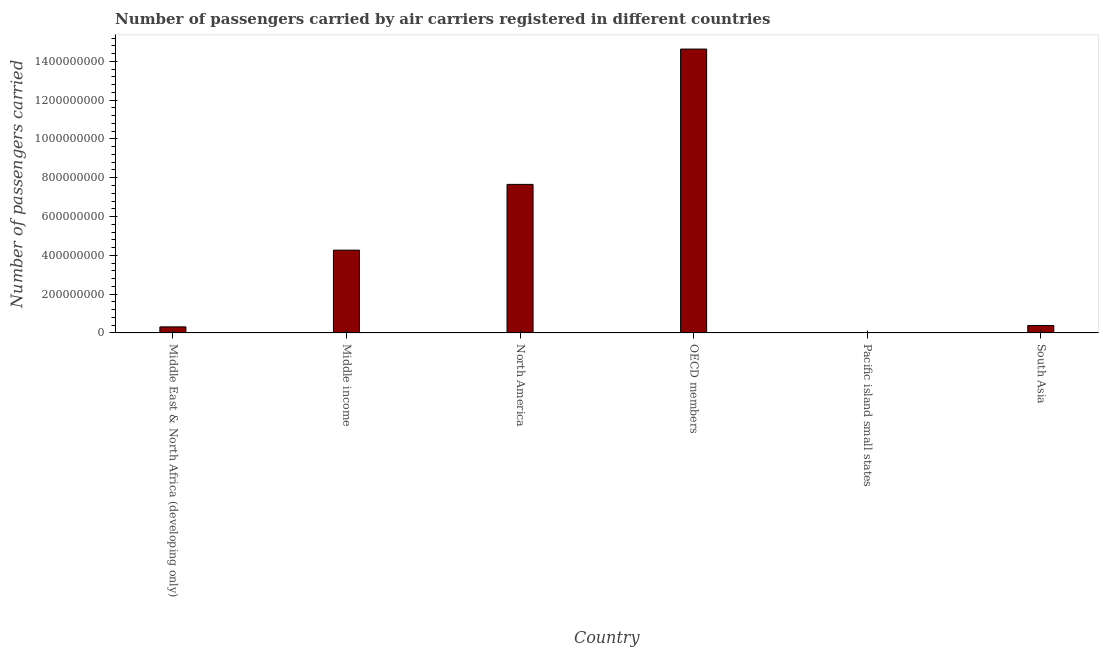Does the graph contain any zero values?
Offer a terse response. No. What is the title of the graph?
Your response must be concise. Number of passengers carried by air carriers registered in different countries. What is the label or title of the X-axis?
Your answer should be compact. Country. What is the label or title of the Y-axis?
Your response must be concise. Number of passengers carried. What is the number of passengers carried in OECD members?
Provide a succinct answer. 1.46e+09. Across all countries, what is the maximum number of passengers carried?
Your answer should be very brief. 1.46e+09. Across all countries, what is the minimum number of passengers carried?
Make the answer very short. 1.37e+06. In which country was the number of passengers carried maximum?
Offer a terse response. OECD members. In which country was the number of passengers carried minimum?
Your response must be concise. Pacific island small states. What is the sum of the number of passengers carried?
Give a very brief answer. 2.73e+09. What is the difference between the number of passengers carried in Middle income and OECD members?
Ensure brevity in your answer.  -1.04e+09. What is the average number of passengers carried per country?
Provide a succinct answer. 4.54e+08. What is the median number of passengers carried?
Give a very brief answer. 2.33e+08. In how many countries, is the number of passengers carried greater than 120000000 ?
Give a very brief answer. 3. What is the ratio of the number of passengers carried in North America to that in South Asia?
Give a very brief answer. 19.99. Is the number of passengers carried in Middle income less than that in South Asia?
Provide a short and direct response. No. What is the difference between the highest and the second highest number of passengers carried?
Ensure brevity in your answer.  6.97e+08. What is the difference between the highest and the lowest number of passengers carried?
Keep it short and to the point. 1.46e+09. In how many countries, is the number of passengers carried greater than the average number of passengers carried taken over all countries?
Offer a terse response. 2. How many bars are there?
Your answer should be compact. 6. Are all the bars in the graph horizontal?
Give a very brief answer. No. How many countries are there in the graph?
Ensure brevity in your answer.  6. What is the difference between two consecutive major ticks on the Y-axis?
Your response must be concise. 2.00e+08. Are the values on the major ticks of Y-axis written in scientific E-notation?
Your answer should be compact. No. What is the Number of passengers carried in Middle East & North Africa (developing only)?
Provide a succinct answer. 3.13e+07. What is the Number of passengers carried of Middle income?
Provide a succinct answer. 4.27e+08. What is the Number of passengers carried of North America?
Provide a succinct answer. 7.66e+08. What is the Number of passengers carried of OECD members?
Ensure brevity in your answer.  1.46e+09. What is the Number of passengers carried in Pacific island small states?
Your response must be concise. 1.37e+06. What is the Number of passengers carried in South Asia?
Provide a succinct answer. 3.83e+07. What is the difference between the Number of passengers carried in Middle East & North Africa (developing only) and Middle income?
Provide a short and direct response. -3.96e+08. What is the difference between the Number of passengers carried in Middle East & North Africa (developing only) and North America?
Give a very brief answer. -7.35e+08. What is the difference between the Number of passengers carried in Middle East & North Africa (developing only) and OECD members?
Keep it short and to the point. -1.43e+09. What is the difference between the Number of passengers carried in Middle East & North Africa (developing only) and Pacific island small states?
Provide a short and direct response. 2.99e+07. What is the difference between the Number of passengers carried in Middle East & North Africa (developing only) and South Asia?
Keep it short and to the point. -7.05e+06. What is the difference between the Number of passengers carried in Middle income and North America?
Ensure brevity in your answer.  -3.39e+08. What is the difference between the Number of passengers carried in Middle income and OECD members?
Provide a succinct answer. -1.04e+09. What is the difference between the Number of passengers carried in Middle income and Pacific island small states?
Provide a short and direct response. 4.25e+08. What is the difference between the Number of passengers carried in Middle income and South Asia?
Give a very brief answer. 3.88e+08. What is the difference between the Number of passengers carried in North America and OECD members?
Give a very brief answer. -6.97e+08. What is the difference between the Number of passengers carried in North America and Pacific island small states?
Give a very brief answer. 7.64e+08. What is the difference between the Number of passengers carried in North America and South Asia?
Provide a short and direct response. 7.27e+08. What is the difference between the Number of passengers carried in OECD members and Pacific island small states?
Your answer should be compact. 1.46e+09. What is the difference between the Number of passengers carried in OECD members and South Asia?
Make the answer very short. 1.42e+09. What is the difference between the Number of passengers carried in Pacific island small states and South Asia?
Provide a short and direct response. -3.69e+07. What is the ratio of the Number of passengers carried in Middle East & North Africa (developing only) to that in Middle income?
Offer a terse response. 0.07. What is the ratio of the Number of passengers carried in Middle East & North Africa (developing only) to that in North America?
Your answer should be compact. 0.04. What is the ratio of the Number of passengers carried in Middle East & North Africa (developing only) to that in OECD members?
Your response must be concise. 0.02. What is the ratio of the Number of passengers carried in Middle East & North Africa (developing only) to that in Pacific island small states?
Offer a very short reply. 22.87. What is the ratio of the Number of passengers carried in Middle East & North Africa (developing only) to that in South Asia?
Provide a short and direct response. 0.82. What is the ratio of the Number of passengers carried in Middle income to that in North America?
Provide a succinct answer. 0.56. What is the ratio of the Number of passengers carried in Middle income to that in OECD members?
Provide a short and direct response. 0.29. What is the ratio of the Number of passengers carried in Middle income to that in Pacific island small states?
Your response must be concise. 312.26. What is the ratio of the Number of passengers carried in Middle income to that in South Asia?
Provide a succinct answer. 11.14. What is the ratio of the Number of passengers carried in North America to that in OECD members?
Give a very brief answer. 0.52. What is the ratio of the Number of passengers carried in North America to that in Pacific island small states?
Keep it short and to the point. 560.32. What is the ratio of the Number of passengers carried in North America to that in South Asia?
Provide a short and direct response. 19.99. What is the ratio of the Number of passengers carried in OECD members to that in Pacific island small states?
Your response must be concise. 1070.63. What is the ratio of the Number of passengers carried in OECD members to that in South Asia?
Keep it short and to the point. 38.2. What is the ratio of the Number of passengers carried in Pacific island small states to that in South Asia?
Give a very brief answer. 0.04. 